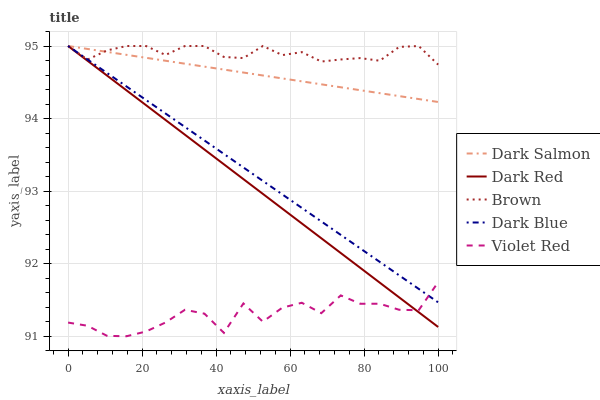Does Violet Red have the minimum area under the curve?
Answer yes or no. Yes. Does Brown have the maximum area under the curve?
Answer yes or no. Yes. Does Dark Blue have the minimum area under the curve?
Answer yes or no. No. Does Dark Blue have the maximum area under the curve?
Answer yes or no. No. Is Dark Salmon the smoothest?
Answer yes or no. Yes. Is Violet Red the roughest?
Answer yes or no. Yes. Is Dark Blue the smoothest?
Answer yes or no. No. Is Dark Blue the roughest?
Answer yes or no. No. Does Violet Red have the lowest value?
Answer yes or no. Yes. Does Dark Blue have the lowest value?
Answer yes or no. No. Does Brown have the highest value?
Answer yes or no. Yes. Does Violet Red have the highest value?
Answer yes or no. No. Is Violet Red less than Dark Salmon?
Answer yes or no. Yes. Is Dark Salmon greater than Violet Red?
Answer yes or no. Yes. Does Brown intersect Dark Salmon?
Answer yes or no. Yes. Is Brown less than Dark Salmon?
Answer yes or no. No. Is Brown greater than Dark Salmon?
Answer yes or no. No. Does Violet Red intersect Dark Salmon?
Answer yes or no. No. 